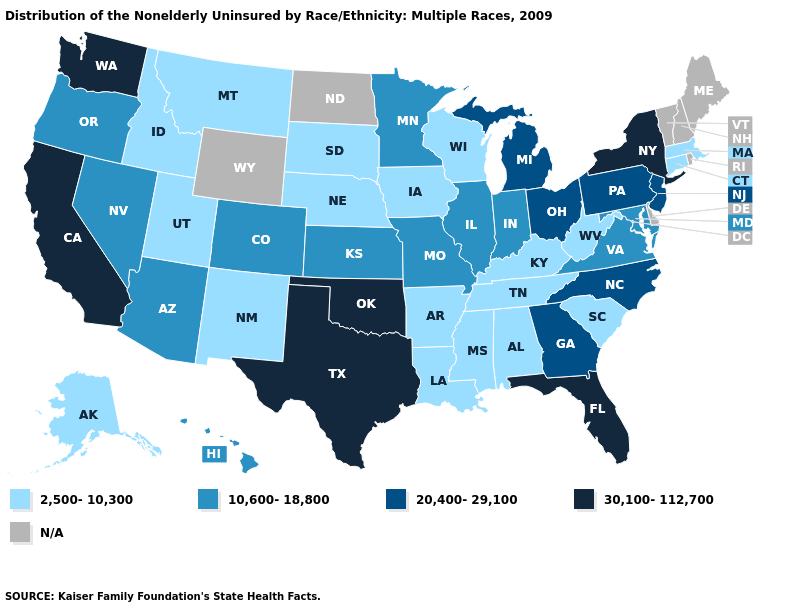Which states have the lowest value in the Northeast?
Give a very brief answer. Connecticut, Massachusetts. What is the value of Maine?
Be succinct. N/A. Name the states that have a value in the range 20,400-29,100?
Keep it brief. Georgia, Michigan, New Jersey, North Carolina, Ohio, Pennsylvania. Which states have the lowest value in the USA?
Write a very short answer. Alabama, Alaska, Arkansas, Connecticut, Idaho, Iowa, Kentucky, Louisiana, Massachusetts, Mississippi, Montana, Nebraska, New Mexico, South Carolina, South Dakota, Tennessee, Utah, West Virginia, Wisconsin. Name the states that have a value in the range 10,600-18,800?
Quick response, please. Arizona, Colorado, Hawaii, Illinois, Indiana, Kansas, Maryland, Minnesota, Missouri, Nevada, Oregon, Virginia. Among the states that border Texas , does Oklahoma have the highest value?
Be succinct. Yes. Among the states that border Nevada , does Idaho have the highest value?
Keep it brief. No. What is the lowest value in states that border Connecticut?
Short answer required. 2,500-10,300. Does Colorado have the highest value in the USA?
Give a very brief answer. No. What is the value of Nevada?
Be succinct. 10,600-18,800. What is the value of Rhode Island?
Concise answer only. N/A. What is the lowest value in the USA?
Keep it brief. 2,500-10,300. Does Ohio have the highest value in the MidWest?
Short answer required. Yes. Name the states that have a value in the range 20,400-29,100?
Be succinct. Georgia, Michigan, New Jersey, North Carolina, Ohio, Pennsylvania. 